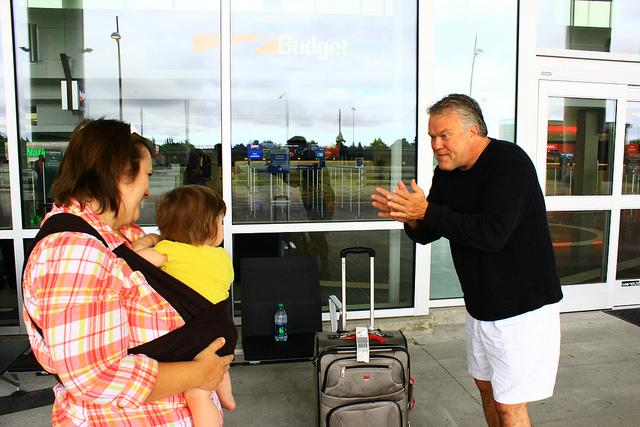What is the woman carrying? Please explain your reasoning. baby. An older woman in plaid is holding a baby in a black holster and a man is talking to the baby. 